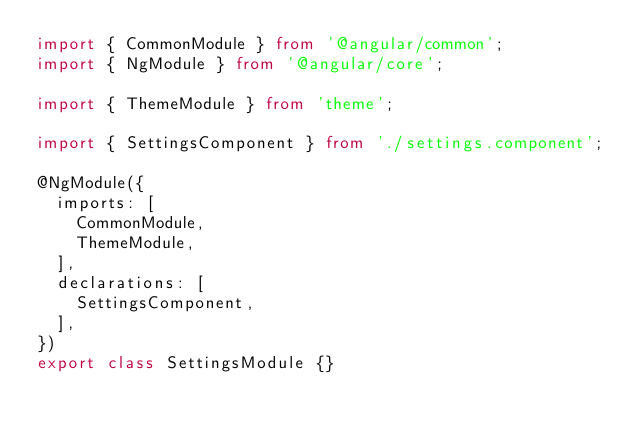<code> <loc_0><loc_0><loc_500><loc_500><_TypeScript_>import { CommonModule } from '@angular/common';
import { NgModule } from '@angular/core';

import { ThemeModule } from 'theme';

import { SettingsComponent } from './settings.component';

@NgModule({
  imports: [
    CommonModule,
    ThemeModule,
  ],
  declarations: [
    SettingsComponent,
  ],
})
export class SettingsModule {}
</code> 